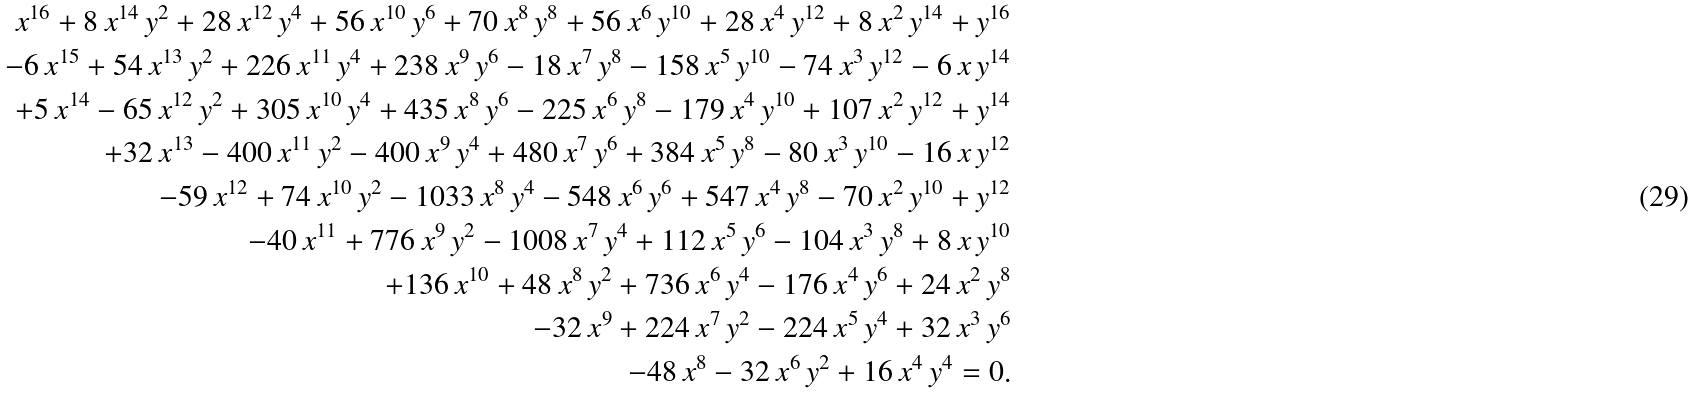<formula> <loc_0><loc_0><loc_500><loc_500>x ^ { 1 6 } + 8 \, x ^ { 1 4 } \, y ^ { 2 } + 2 8 \, x ^ { 1 2 } \, y ^ { 4 } + 5 6 \, x ^ { 1 0 } \, y ^ { 6 } + 7 0 \, x ^ { 8 } \, y ^ { 8 } + 5 6 \, x ^ { 6 } \, y ^ { 1 0 } + 2 8 \, x ^ { 4 } \, y ^ { 1 2 } + 8 \, x ^ { 2 } \, y ^ { 1 4 } + y ^ { 1 6 } \\ - 6 \, x ^ { 1 5 } + 5 4 \, x ^ { 1 3 } \, y ^ { 2 } + 2 2 6 \, x ^ { 1 1 } \, y ^ { 4 } + 2 3 8 \, x ^ { 9 } \, y ^ { 6 } - 1 8 \, x ^ { 7 } \, y ^ { 8 } - 1 5 8 \, x ^ { 5 } \, y ^ { 1 0 } - 7 4 \, x ^ { 3 } \, y ^ { 1 2 } - 6 \, x \, y ^ { 1 4 } \\ + 5 \, x ^ { 1 4 } - 6 5 \, x ^ { 1 2 } \, y ^ { 2 } + 3 0 5 \, x ^ { 1 0 } \, y ^ { 4 } + 4 3 5 \, x ^ { 8 } \, y ^ { 6 } - 2 2 5 \, x ^ { 6 } \, y ^ { 8 } - 1 7 9 \, x ^ { 4 } \, y ^ { 1 0 } + 1 0 7 \, x ^ { 2 } \, y ^ { 1 2 } + y ^ { 1 4 } \\ + 3 2 \, x ^ { 1 3 } - 4 0 0 \, x ^ { 1 1 } \, y ^ { 2 } - 4 0 0 \, x ^ { 9 } \, y ^ { 4 } + 4 8 0 \, x ^ { 7 } \, y ^ { 6 } + 3 8 4 \, x ^ { 5 } \, y ^ { 8 } - 8 0 \, x ^ { 3 } \, y ^ { 1 0 } - 1 6 \, x \, y ^ { 1 2 } \\ - 5 9 \, x ^ { 1 2 } + 7 4 \, x ^ { 1 0 } \, y ^ { 2 } - 1 0 3 3 \, x ^ { 8 } \, y ^ { 4 } - 5 4 8 \, x ^ { 6 } \, y ^ { 6 } + 5 4 7 \, x ^ { 4 } \, y ^ { 8 } - 7 0 \, x ^ { 2 } \, y ^ { 1 0 } + y ^ { 1 2 } \\ - 4 0 \, x ^ { 1 1 } + 7 7 6 \, x ^ { 9 } \, y ^ { 2 } - 1 0 0 8 \, x ^ { 7 } \, y ^ { 4 } + 1 1 2 \, x ^ { 5 } \, y ^ { 6 } - 1 0 4 \, x ^ { 3 } \, y ^ { 8 } + 8 \, x \, y ^ { 1 0 } \\ + 1 3 6 \, x ^ { 1 0 } + 4 8 \, x ^ { 8 } \, y ^ { 2 } + 7 3 6 \, x ^ { 6 } \, y ^ { 4 } - 1 7 6 \, x ^ { 4 } \, y ^ { 6 } + 2 4 \, x ^ { 2 } \, y ^ { 8 } \\ - 3 2 \, x ^ { 9 } + 2 2 4 \, x ^ { 7 } \, y ^ { 2 } - 2 2 4 \, x ^ { 5 } \, y ^ { 4 } + 3 2 \, x ^ { 3 } \, y ^ { 6 } \\ - 4 8 \, x ^ { 8 } - 3 2 \, x ^ { 6 } \, y ^ { 2 } + 1 6 \, x ^ { 4 } \, y ^ { 4 } = 0 .</formula> 